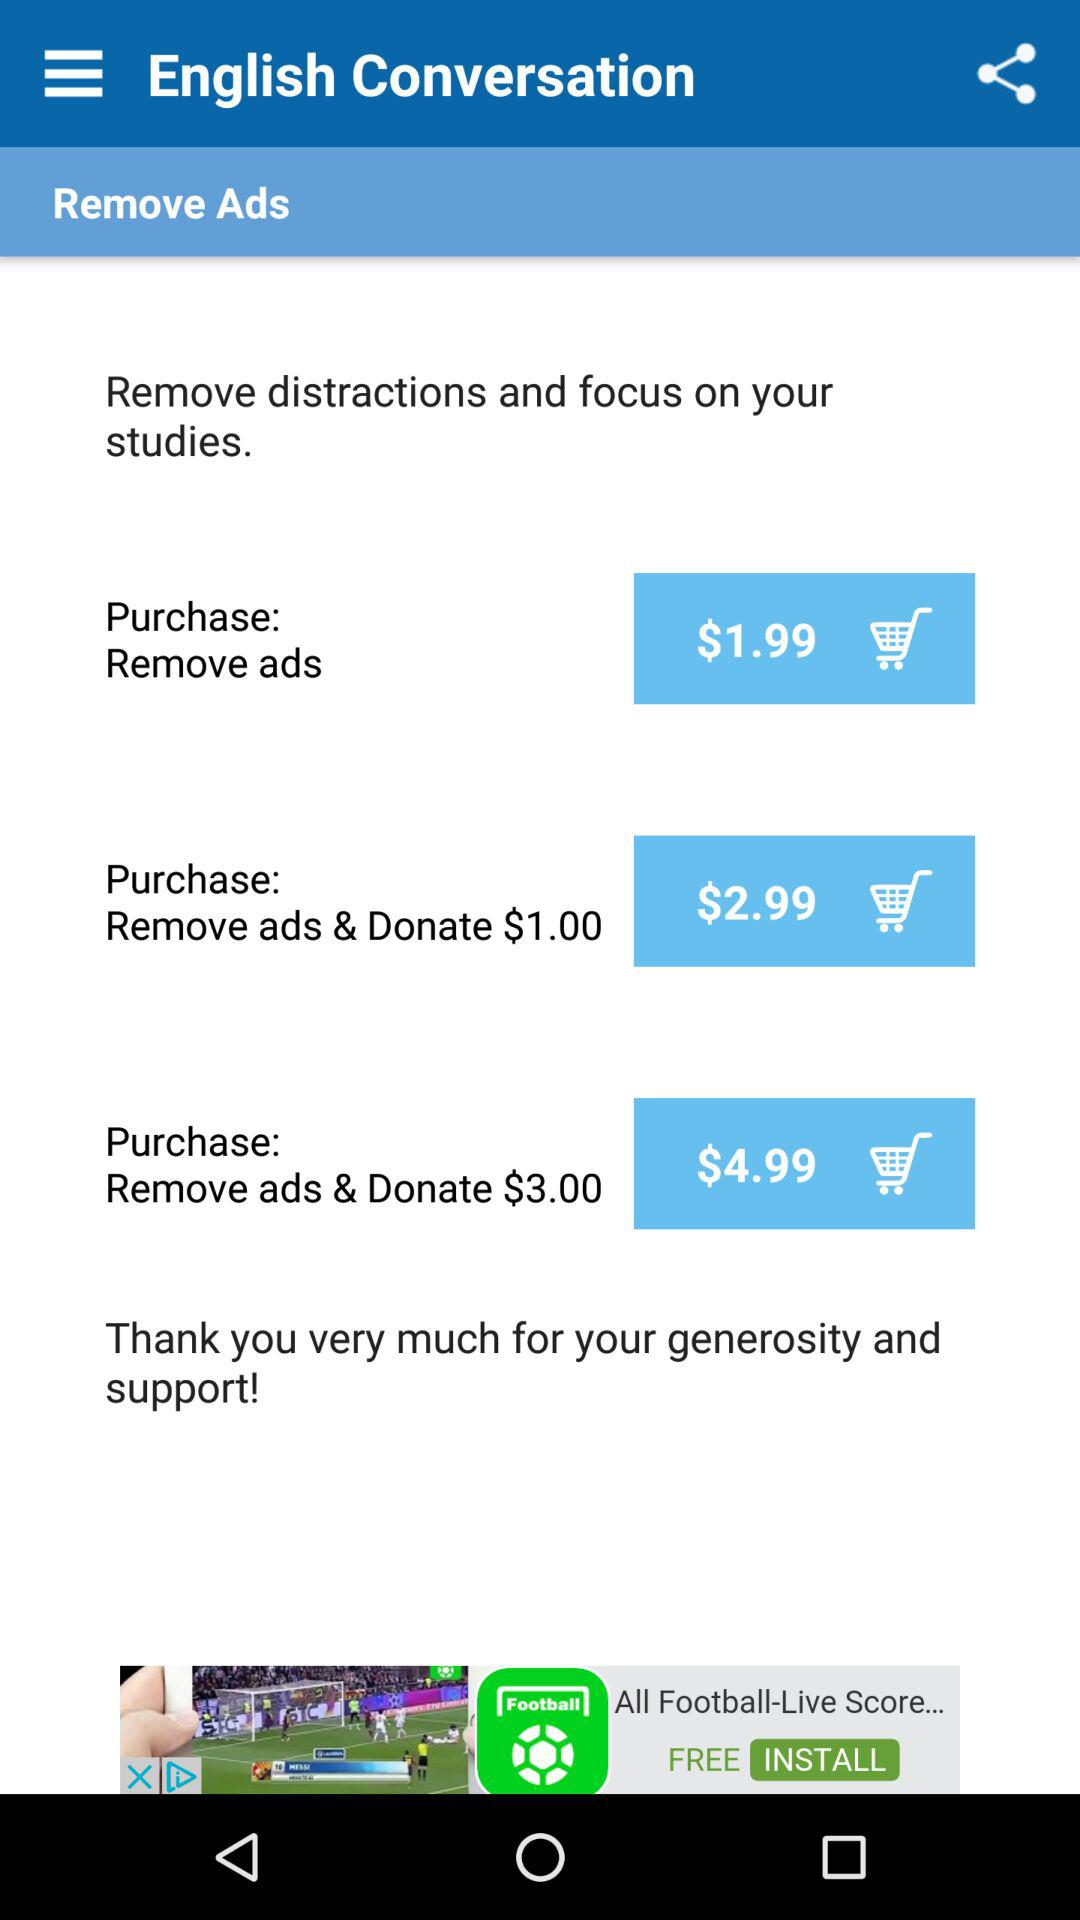What is the price of "Remove ads & Donate $3.00"? The price is $4.99. 